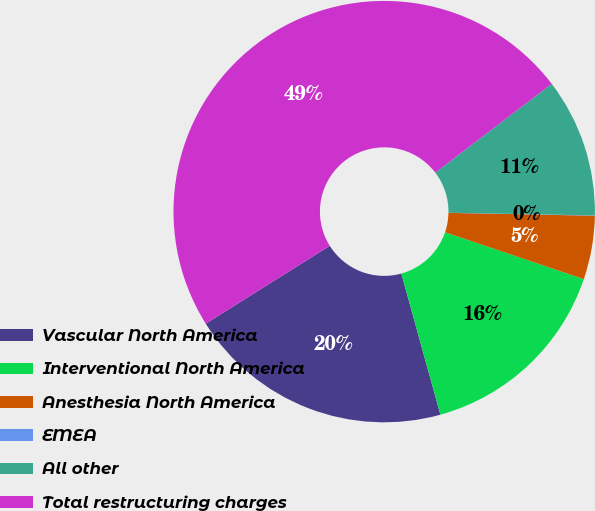<chart> <loc_0><loc_0><loc_500><loc_500><pie_chart><fcel>Vascular North America<fcel>Interventional North America<fcel>Anesthesia North America<fcel>EMEA<fcel>All other<fcel>Total restructuring charges<nl><fcel>20.37%<fcel>15.51%<fcel>4.88%<fcel>0.02%<fcel>10.66%<fcel>48.55%<nl></chart> 